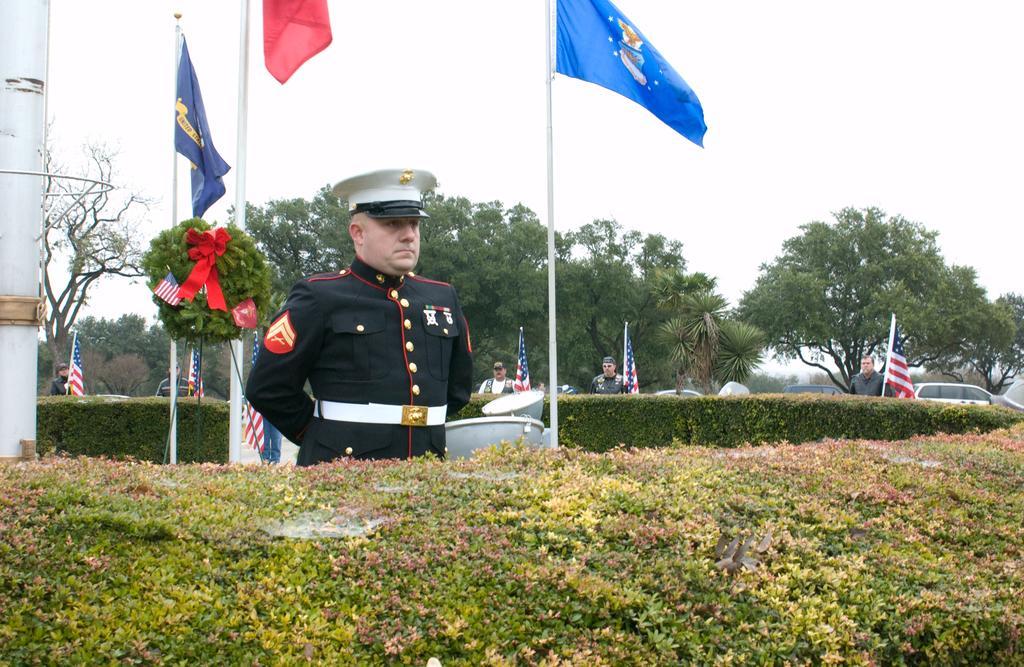Please provide a concise description of this image. As we can see in the image there are plants, trees, flags, cars and sky. 